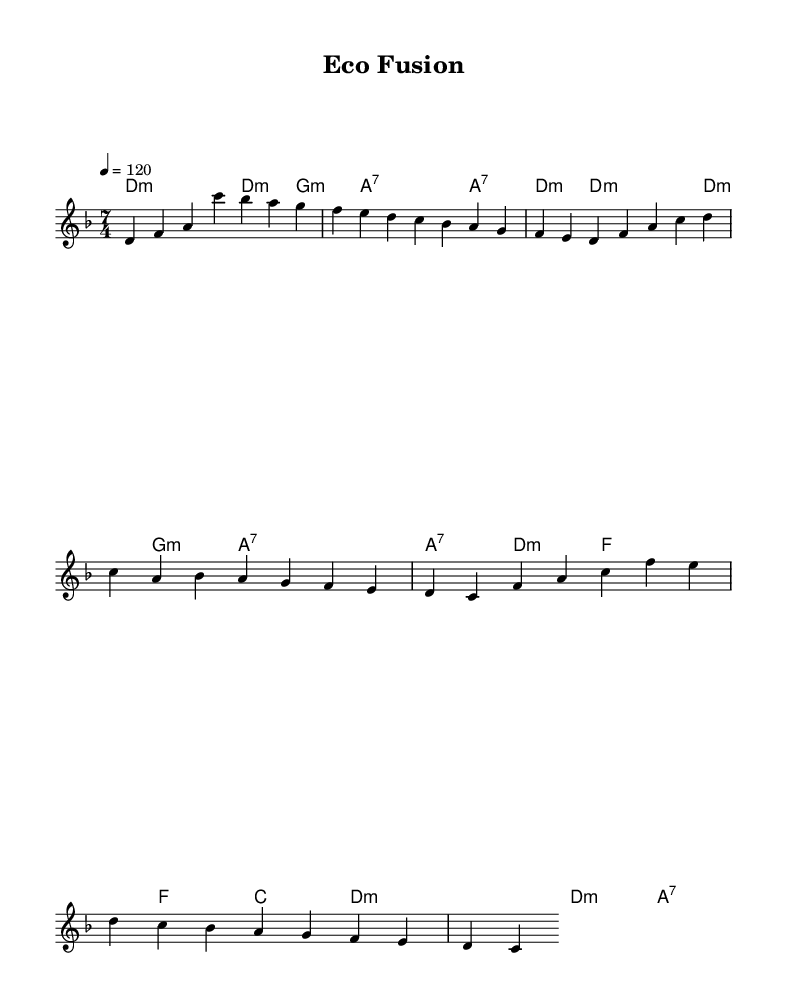What is the key signature of this music? The key signature can be determined from the key indicated in the global section of the code, which states "key d minor". The key of D minor has one flat, B flat.
Answer: D minor What is the time signature of the piece? The time signature is specified in the global section as "time 7/4", which indicates that there are seven beats per measure, and each beat is a quarter note.
Answer: 7/4 What is the tempo marking for this composition? The tempo is indicated in the global section where it states "tempo 4 = 120", meaning there are 120 quarter notes per minute.
Answer: 120 How many measures are in the melody? By counting the melody line provided, we see there are two sections (Intro and Verse plus Chorus), each with distinct measure counts. The total count is 8 measures for the melody line.
Answer: 8 What style of music does this piece represent? The genre can be inferred from the title "Eco Fusion", which suggests a blend of jazz-rock fusion with themes of environmental awareness. This style involves improvisation and rhythmic complexity typical of fusion.
Answer: Jazz-rock fusion What environmental theme is expressed in the lyrics? The lyrics mention "oceans warming" and "nature's balance slowly transforming", indicating a focus on environmental issues such as climate change and ecological balance.
Answer: Oceans warming How does the structure of this piece support a fusion style? The piece combines complex time signatures and progressive harmonic changes typical in jazz-rock fusion, along with lyrical content that reflects scientific and environmental themes, creating a blend of musicality and message.
Answer: Complex time signatures 